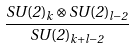Convert formula to latex. <formula><loc_0><loc_0><loc_500><loc_500>\frac { S U ( 2 ) _ { k } \otimes S U ( 2 ) _ { l - 2 } } { S U ( 2 ) _ { k + l - 2 } }</formula> 